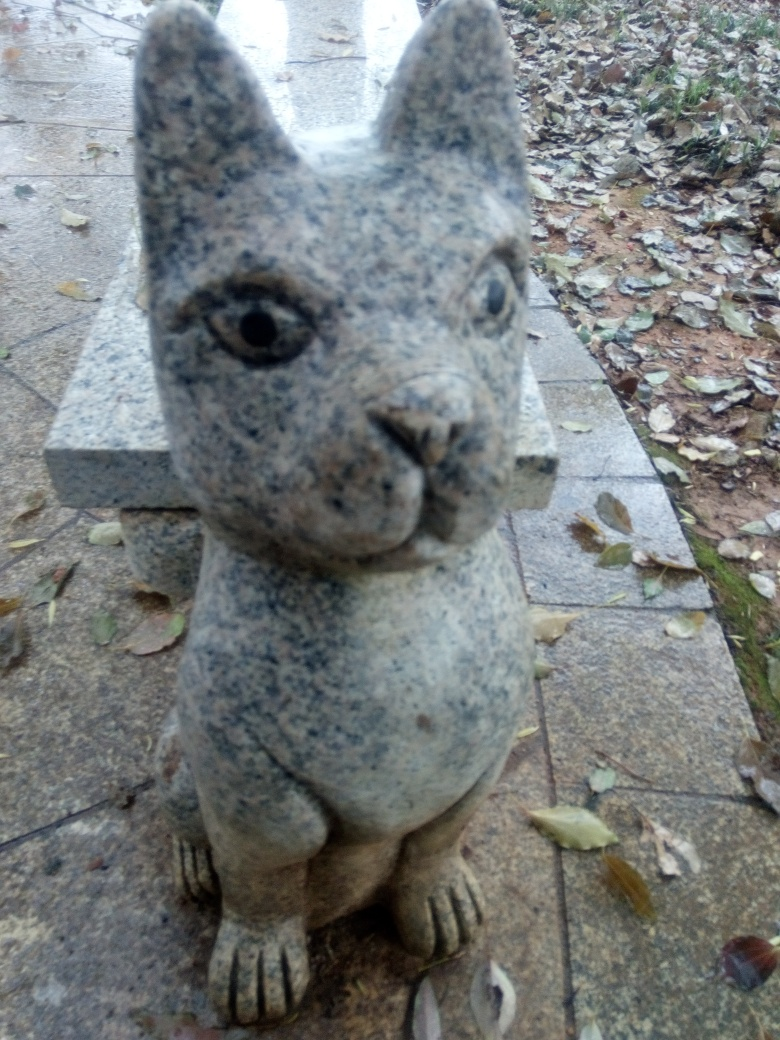Are there any quality issues with this image? Yes, there are several quality issues with the image. The focus is soft, likely due to camera shake or a low depth of field, which causes a lack of sharpness in the details of the statue. Additionally, the lighting is flat, reducing the visual impact of the image. There's also a noticeable tilt to the left, which could be corrected for better composition. 